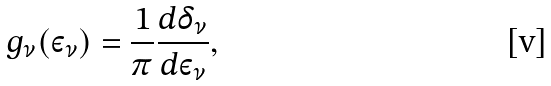Convert formula to latex. <formula><loc_0><loc_0><loc_500><loc_500>g _ { \nu } ( \varepsilon _ { \nu } ) = \frac { 1 } { \pi } \frac { d \delta _ { \nu } } { d \varepsilon _ { \nu } } ,</formula> 